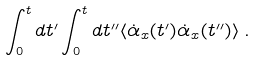<formula> <loc_0><loc_0><loc_500><loc_500>\int _ { 0 } ^ { t } d t ^ { \prime } \int _ { 0 } ^ { t } d t ^ { \prime \prime } \langle \dot { \alpha } _ { x } ( t ^ { \prime } ) \dot { \alpha } _ { x } ( t ^ { \prime \prime } ) \rangle \, .</formula> 